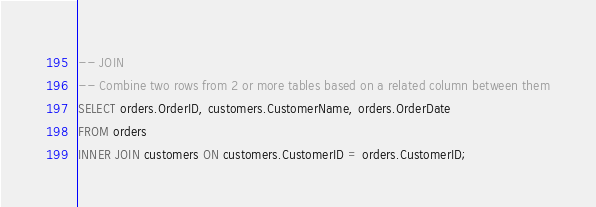Convert code to text. <code><loc_0><loc_0><loc_500><loc_500><_SQL_>-- JOIN
-- Combine two rows from 2 or more tables based on a related column between them
SELECT orders.OrderID, customers.CustomerName, orders.OrderDate
FROM orders
INNER JOIN customers ON customers.CustomerID = orders.CustomerID;
</code> 